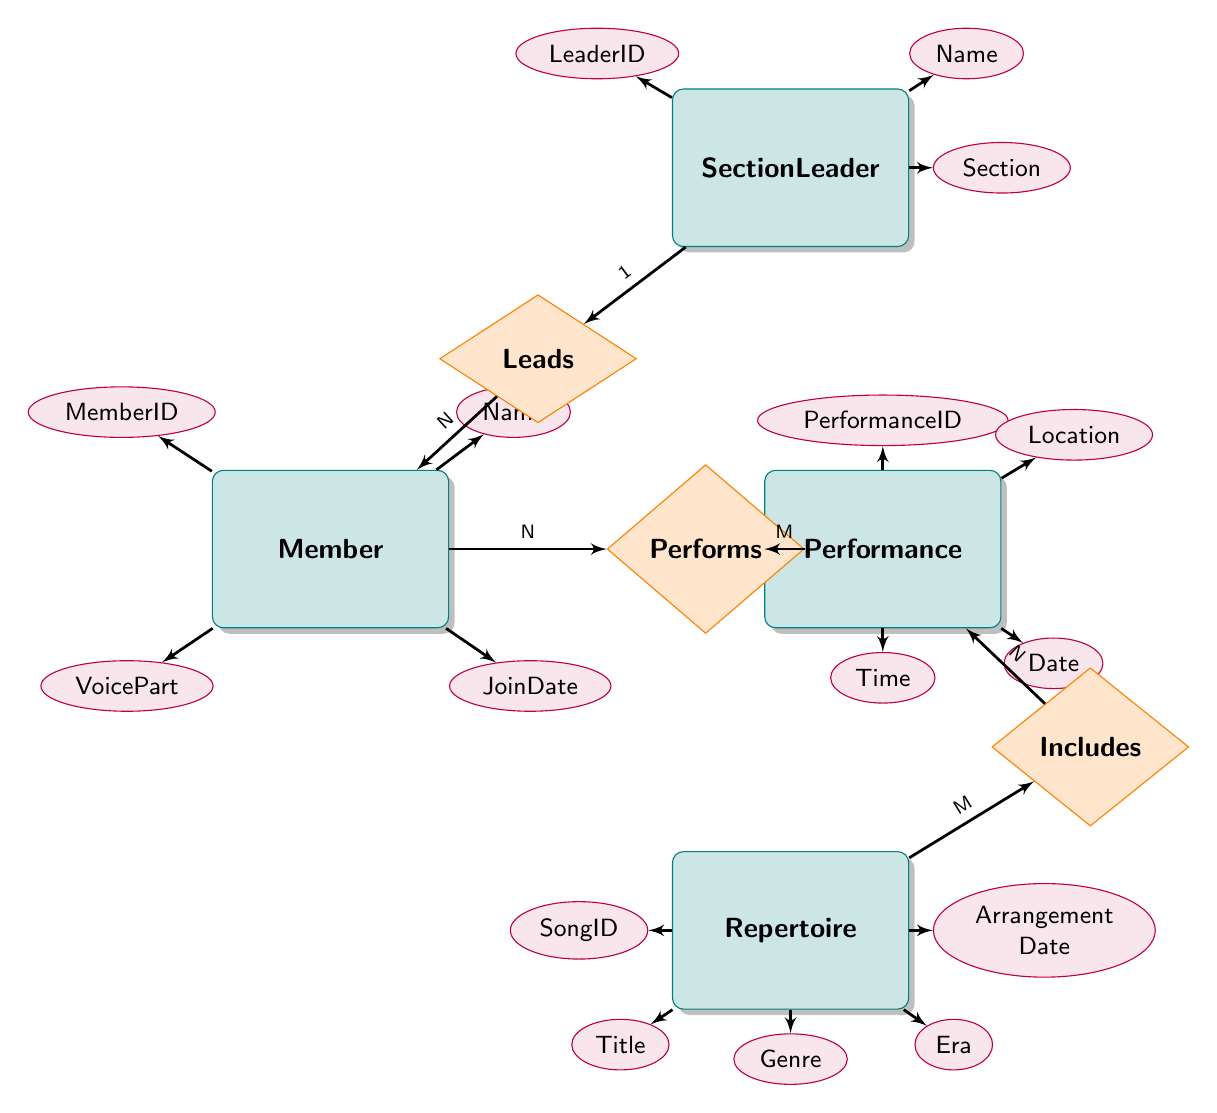What is the primary key of the Member entity? The primary key attribute is labeled directly in the Member entity, which is indicated in the diagram as MemberID. This uniquely identifies each member in the organization.
Answer: MemberID How many relationships are present in the diagram? To find the number of relationships, count the sections labeled with relationship names; there are three relationships: Leads, Performs, and Includes.
Answer: 3 Which entity is connected to the Performance entity through a many-to-many relationship? The Performs relationship connects the Member entity to the Performance entity, indicating that many members can participate in many performances. This is typically represented by a join table.
Answer: Member Who leads the members in a Section? The relationship labeled "Leads" in the diagram connects the SectionLeader entity to the Member entity, indicating that each SectionLeader can lead multiple members, thus they play an integral leadership role in the organization.
Answer: SectionLeader What is the relationship between Repertoire and Performance? The Includes relationship connects the Repertoire entity to the Performance entity, detailing that multiple songs (Repertoire) can be performed at multiple performances.
Answer: Includes How many attributes are listed under the Performance entity? The Performance entity has four attributes indicated in the diagram: PerformanceID, Location, Date, and Time. Counting these will give the total attributes for this entity.
Answer: 4 Which entity has the attribute "VoicePart"? By examining the attributes of the Member entity, we can see "VoicePart" is listed there, indicating it is specific to members of the a cappella group.
Answer: Member What is the cardinality of the relationship between SectionLeader and Member? The "Leads" relationship shows a cardinality of 1 to many, meaning one SectionLeader can lead multiple members. This is indicated directly next to the relationship line in the diagram.
Answer: 1 to many What is the primary key of the Repertoire entity? The primary key for the Repertoire entity is clearly marked as SongID in the diagram. This uniquely identifies each song in the repertoire.
Answer: SongID 